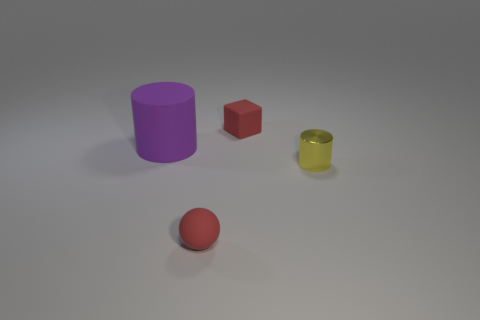Add 1 large purple matte cubes. How many objects exist? 5 Subtract all yellow cylinders. How many cylinders are left? 1 Subtract 1 cylinders. How many cylinders are left? 1 Subtract all cubes. How many objects are left? 3 Subtract all tiny red things. Subtract all tiny red blocks. How many objects are left? 1 Add 1 yellow cylinders. How many yellow cylinders are left? 2 Add 4 yellow cylinders. How many yellow cylinders exist? 5 Subtract 0 purple balls. How many objects are left? 4 Subtract all purple cubes. Subtract all brown spheres. How many cubes are left? 1 